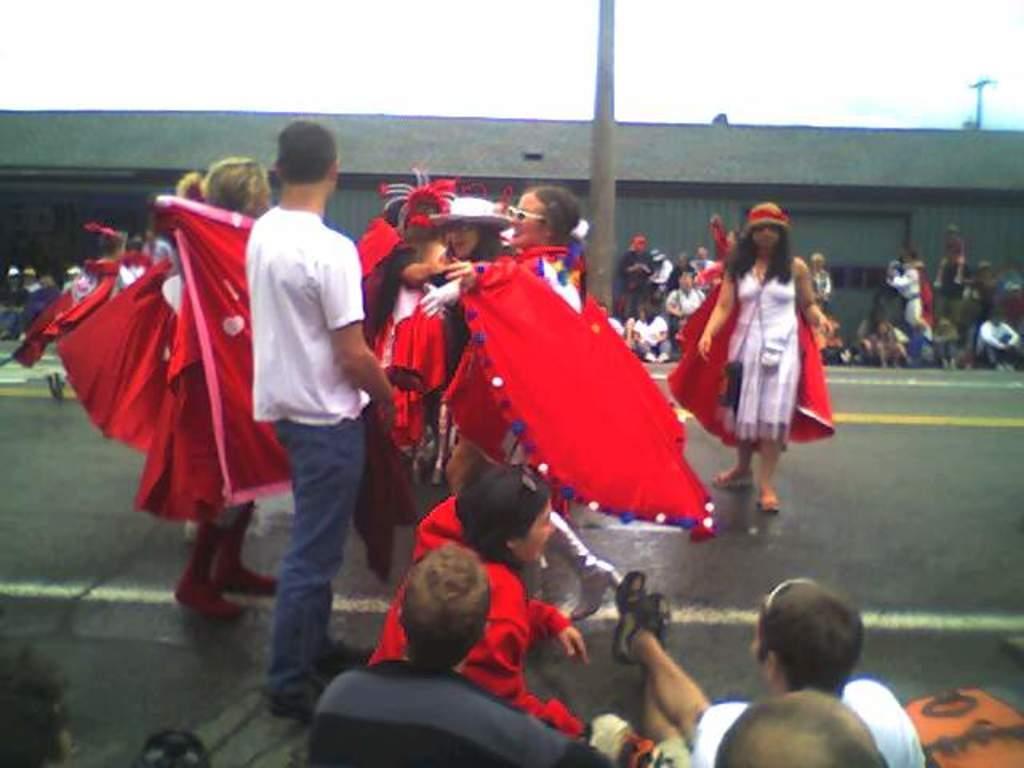Describe this image in one or two sentences. In this picture we can observe some people standing on the road. We can observe red color costumes in this picture. There are men and women. We can observe a tree. In the background we can observe a warehouse and a sky. 